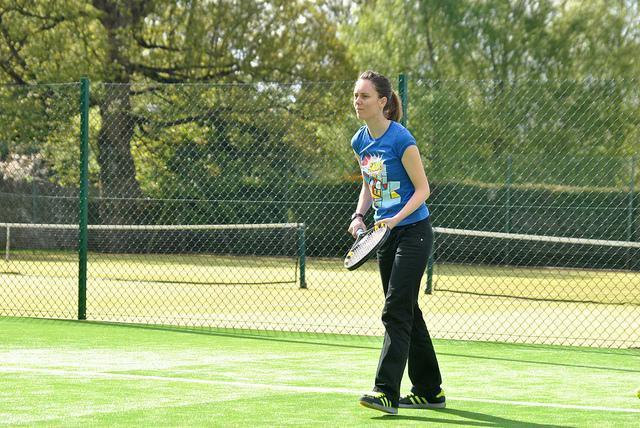How many people are there?
Give a very brief answer. 1. 